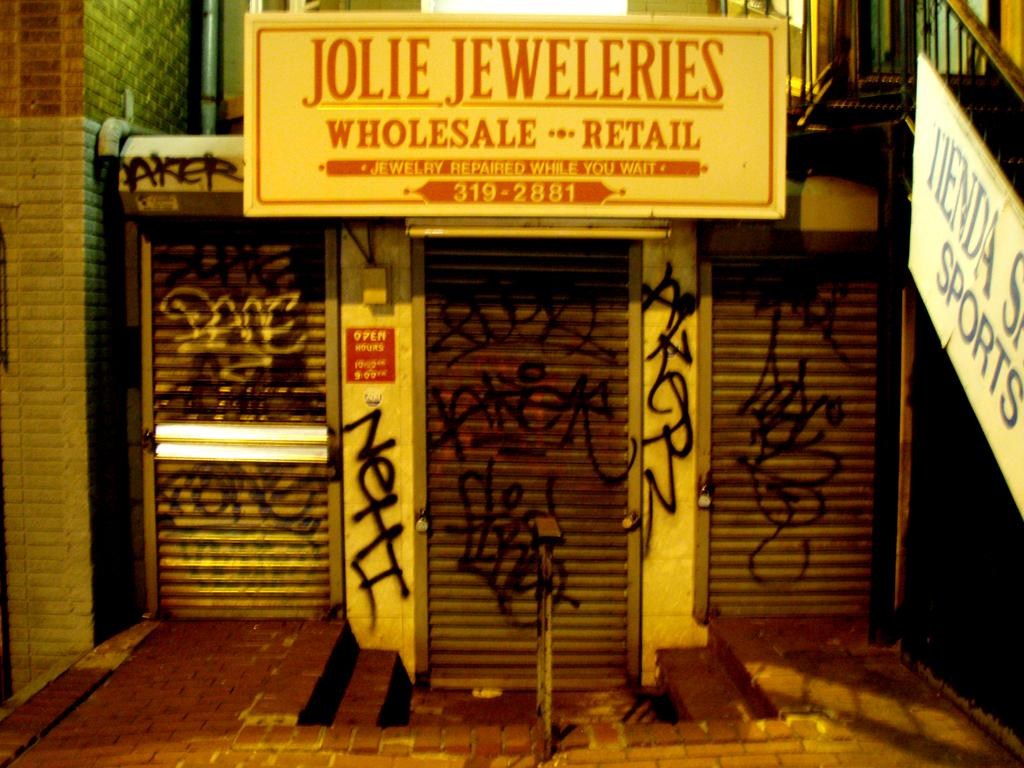Provide a one-sentence caption for the provided image. Jolie Jeweleries, a wholesale retail shop that repairs while you wait, sits shuttered and covered in graffiti. 